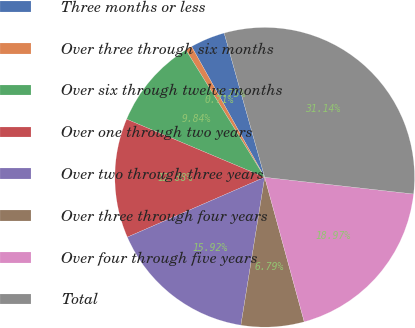Convert chart. <chart><loc_0><loc_0><loc_500><loc_500><pie_chart><fcel>Three months or less<fcel>Over three through six months<fcel>Over six through twelve months<fcel>Over one through two years<fcel>Over two through three years<fcel>Over three through four years<fcel>Over four through five years<fcel>Total<nl><fcel>3.75%<fcel>0.71%<fcel>9.84%<fcel>12.88%<fcel>15.92%<fcel>6.79%<fcel>18.97%<fcel>31.14%<nl></chart> 